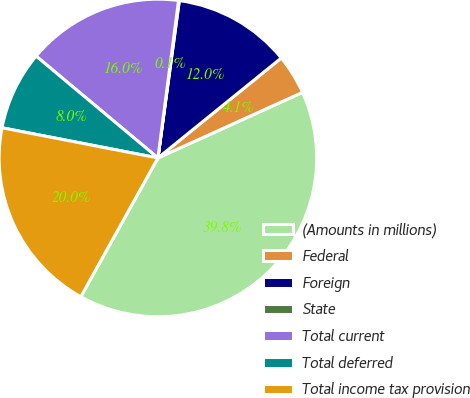<chart> <loc_0><loc_0><loc_500><loc_500><pie_chart><fcel>(Amounts in millions)<fcel>Federal<fcel>Foreign<fcel>State<fcel>Total current<fcel>Total deferred<fcel>Total income tax provision<nl><fcel>39.85%<fcel>4.06%<fcel>12.01%<fcel>0.08%<fcel>15.99%<fcel>8.04%<fcel>19.97%<nl></chart> 